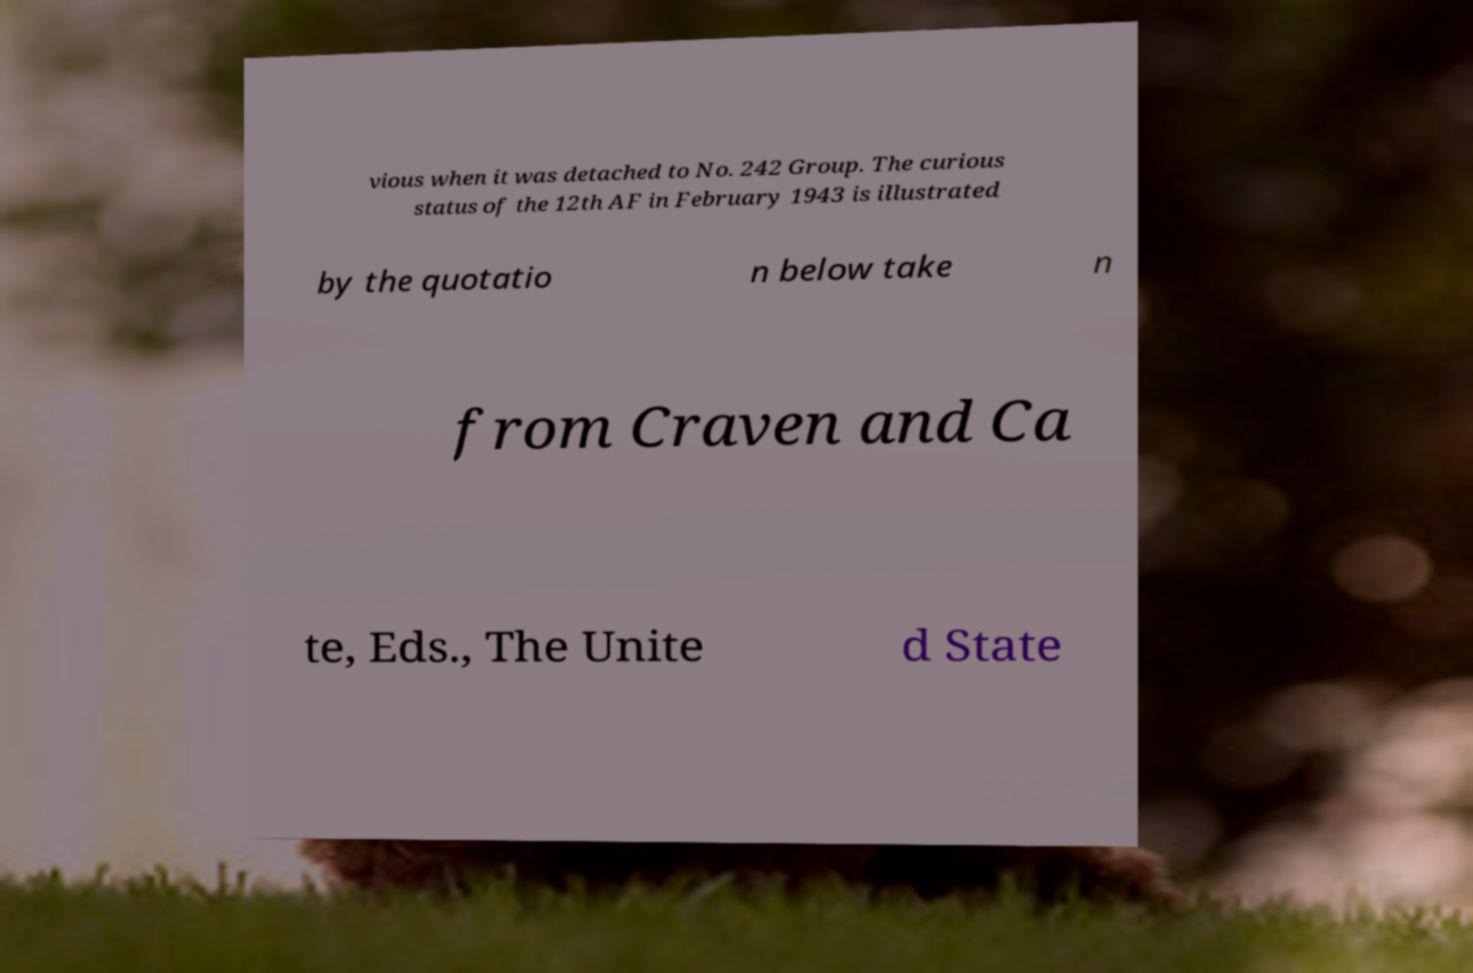Please read and relay the text visible in this image. What does it say? vious when it was detached to No. 242 Group. The curious status of the 12th AF in February 1943 is illustrated by the quotatio n below take n from Craven and Ca te, Eds., The Unite d State 